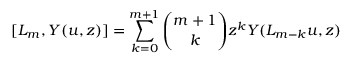Convert formula to latex. <formula><loc_0><loc_0><loc_500><loc_500>[ L _ { m } , Y ( u , z ) ] = \sum _ { k = 0 } ^ { m + 1 } { \binom { m + 1 } { k } } z ^ { k } Y ( L _ { m - k } u , z )</formula> 